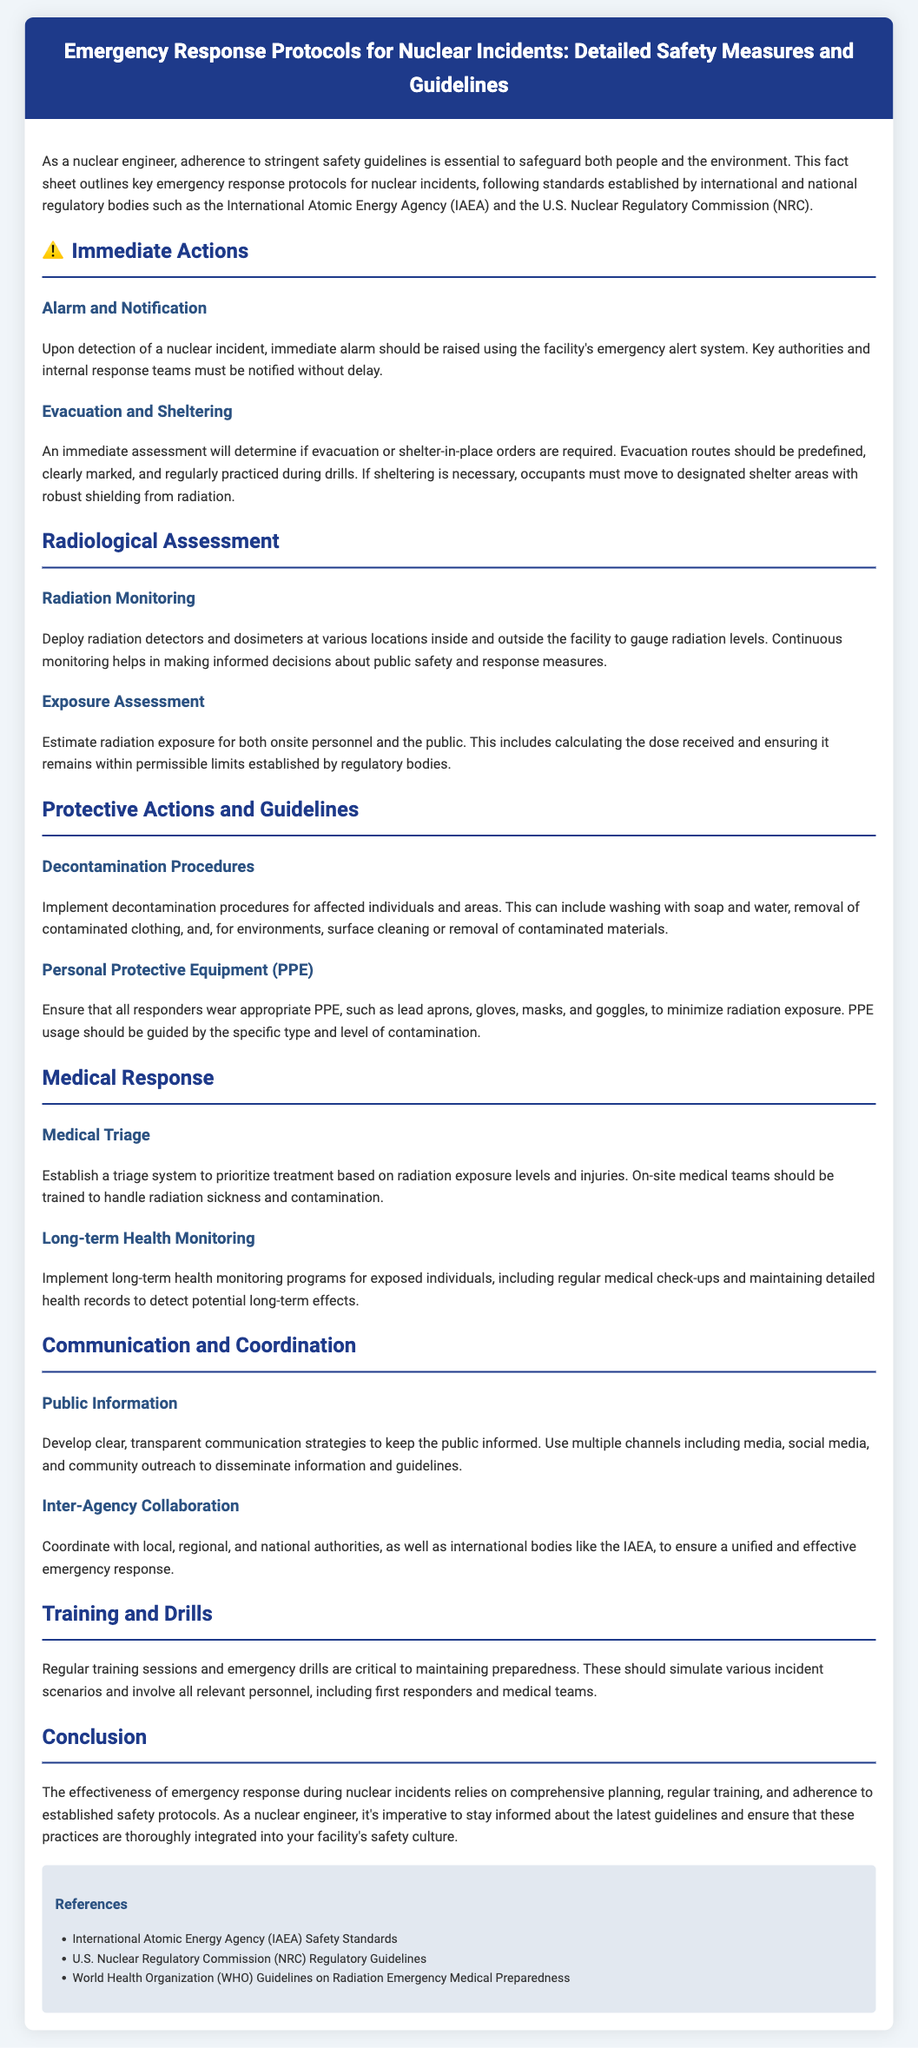What is the title of the document? The title of the document is included in the header section, summarizing the content about emergency response protocols for nuclear incidents.
Answer: Emergency Response Protocols for Nuclear Incidents: Detailed Safety Measures and Guidelines What is the main authority mentioned for regulatory guidelines? The document mentions international and national regulatory bodies that provide safety guidelines, focusing on the IAEA and NRC.
Answer: International Atomic Energy Agency (IAEA) What immediate action is required upon detection of a nuclear incident? The document states that the first step is to raise an immediate alarm using the facility's emergency alert system.
Answer: Alarm and Notification Which personal protective equipment is emphasized for responders? The section on Personal Protective Equipment highlights specific types that are necessary to minimize radiation exposure.
Answer: Lead aprons, gloves, masks, and goggles What should be done for individuals who are exposed to radiation? There is a section that discusses the importance of long-term health monitoring programs for those exposed to radiation.
Answer: Long-term health monitoring How should public information be communicated during a nuclear incident? The document outlines strategies for communication, particularly focusing on transparency and utilizing multiple channels for dissemination.
Answer: Clear, transparent communication strategies What is the purpose of conducting regular training sessions and drills? The document emphasizes their significance in maintaining preparedness for responding to various incident scenarios.
Answer: Maintaining preparedness What is the first step in assessing radiation risk? It states that deploying radiation detectors and dosimeters is essential for gauging radiation levels.
Answer: Radiation Monitoring 